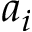<formula> <loc_0><loc_0><loc_500><loc_500>a _ { i }</formula> 